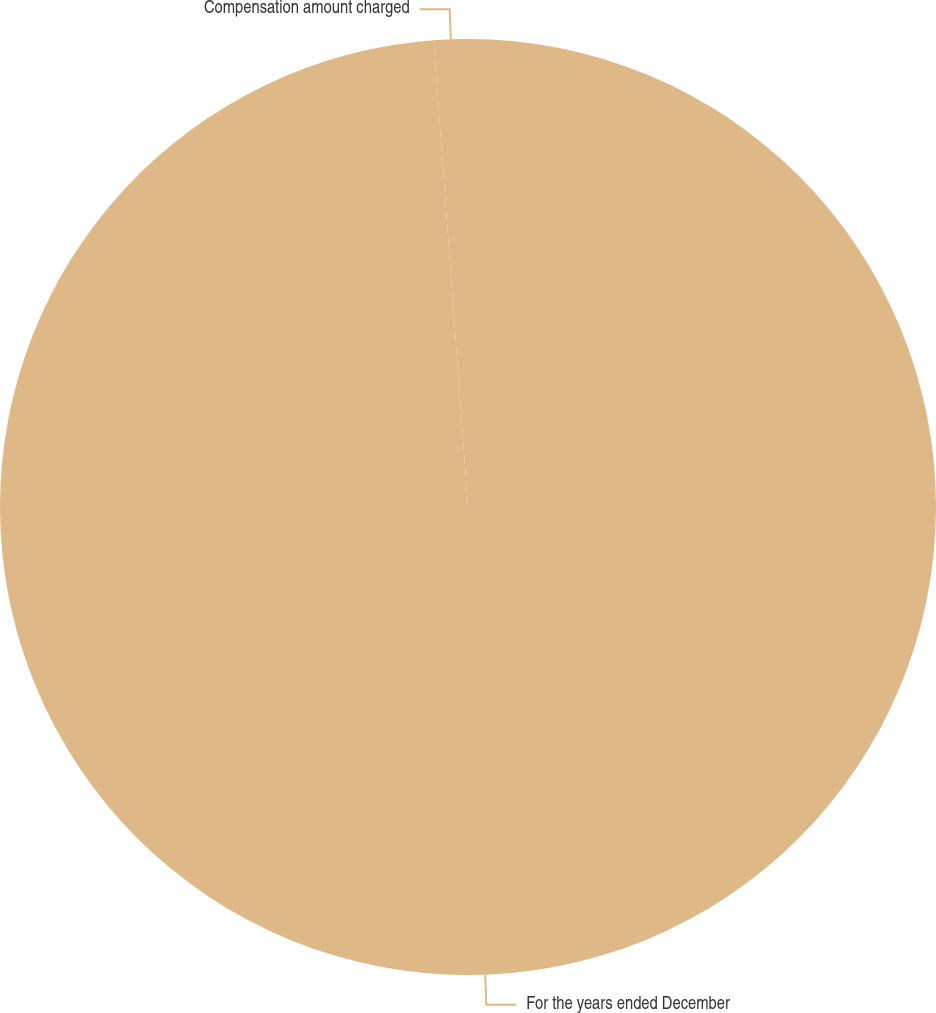<chart> <loc_0><loc_0><loc_500><loc_500><pie_chart><fcel>For the years ended December<fcel>Compensation amount charged<nl><fcel>98.83%<fcel>1.17%<nl></chart> 